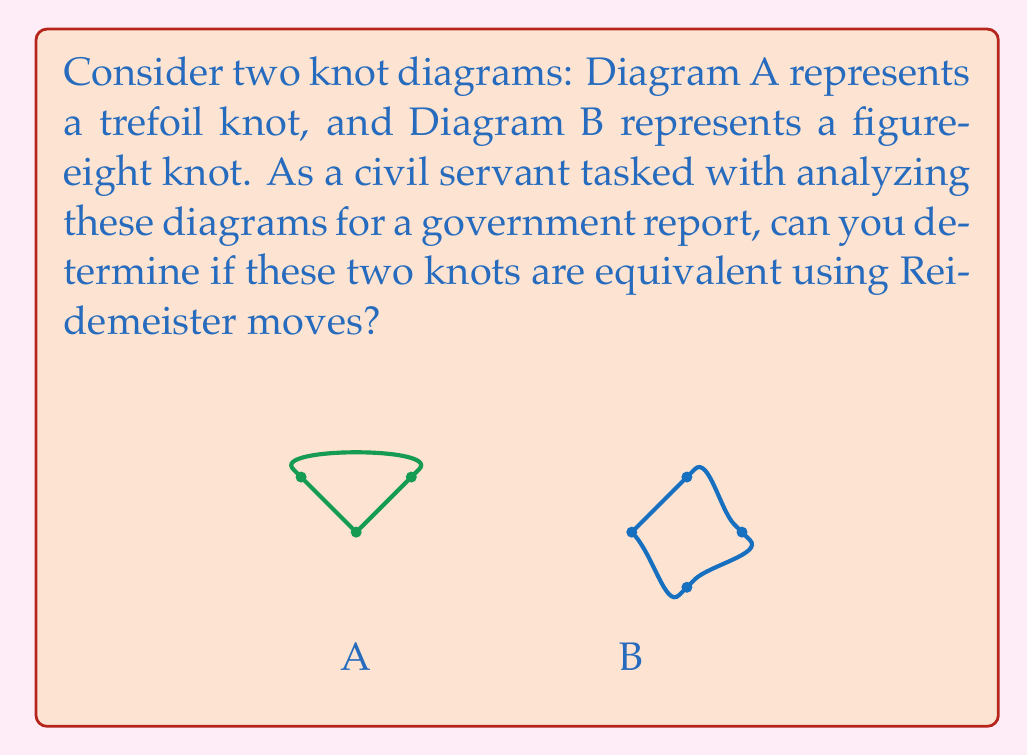Help me with this question. To determine if two knot diagrams represent the same knot, we need to check if one can be transformed into the other using Reidemeister moves. Let's analyze this step-by-step:

1. Recall the three types of Reidemeister moves:
   - Type I: Adding or removing a twist
   - Type II: Moving one strand completely over or under another
   - Type III: Moving a strand over or under a crossing

2. Trefoil knot (Diagram A):
   - Has three crossings
   - All crossings are of the same type (all over or all under)

3. Figure-eight knot (Diagram B):
   - Has four crossings
   - Alternating over and under crossings

4. Attempt to transform Diagram A into Diagram B:
   - We cannot reduce the number of crossings in the trefoil knot using Reidemeister moves
   - Adding a crossing to the trefoil (Type I move) would result in four crossings, but not in the alternating pattern of the figure-eight knot

5. Attempt to transform Diagram B into Diagram A:
   - We cannot reduce the number of crossings in the figure-eight knot to three using Reidemeister moves
   - Changing the crossing pattern would require moves that are not Reidemeister moves

6. Invariants:
   - The trefoil knot has a crossing number of 3
   - The figure-eight knot has a crossing number of 4
   - Crossing number is a knot invariant and cannot be changed by Reidemeister moves

Therefore, it is impossible to transform one diagram into the other using only Reidemeister moves, proving that these two knots are not equivalent.
Answer: Not equivalent 